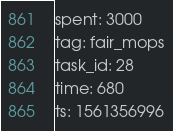<code> <loc_0><loc_0><loc_500><loc_500><_YAML_>spent: 3000
tag: fair_mops
task_id: 28
time: 680
ts: 1561356996
</code> 